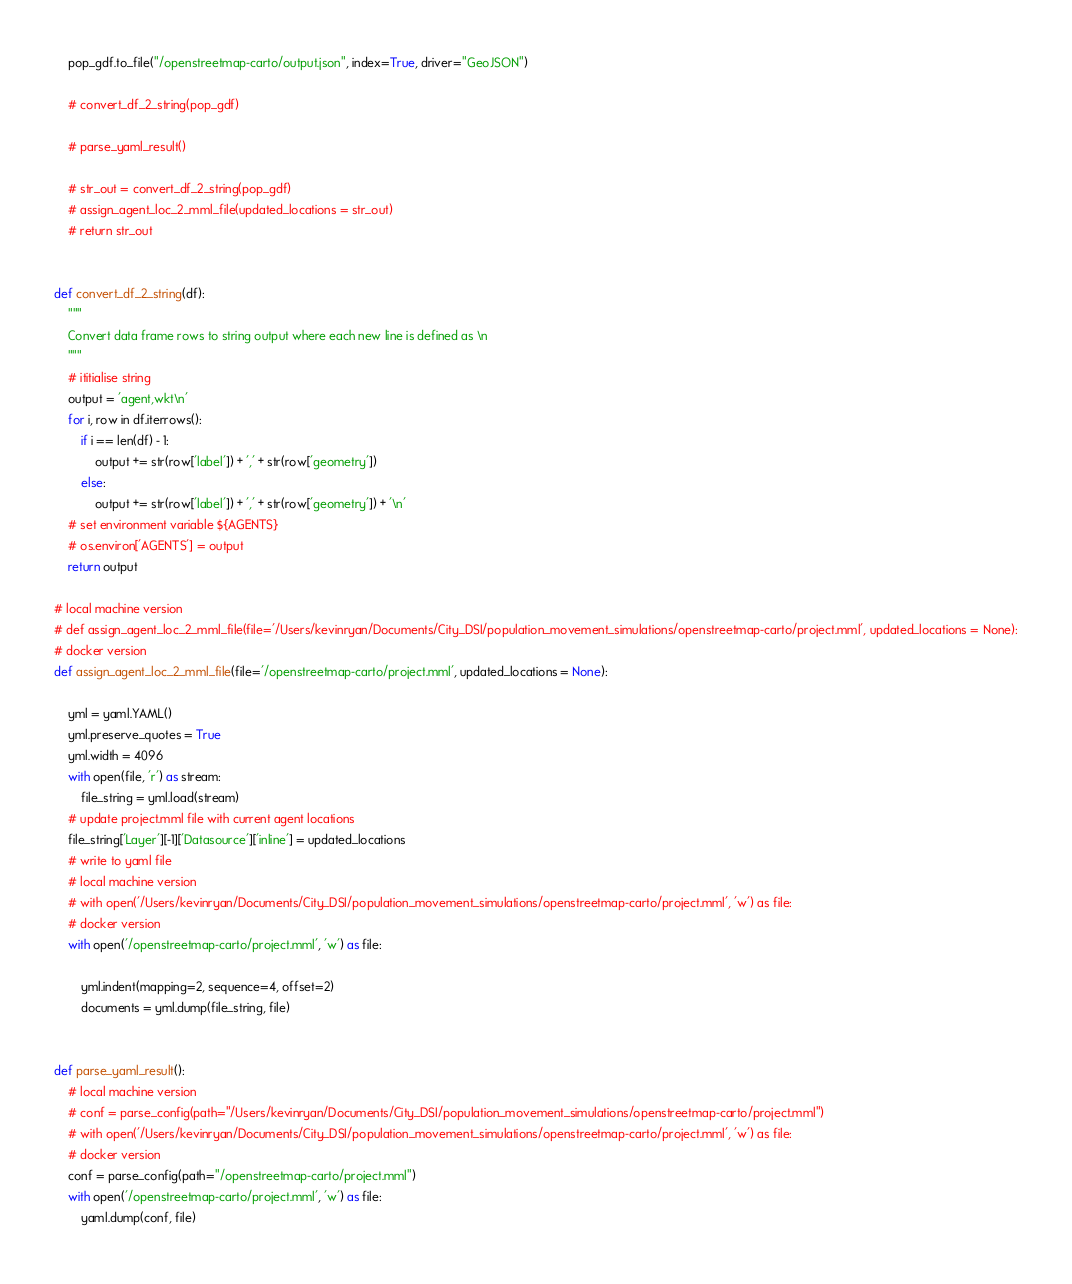Convert code to text. <code><loc_0><loc_0><loc_500><loc_500><_Python_>    pop_gdf.to_file("/openstreetmap-carto/output.json", index=True, driver="GeoJSON")

    # convert_df_2_string(pop_gdf)

    # parse_yaml_result()

    # str_out = convert_df_2_string(pop_gdf)
    # assign_agent_loc_2_mml_file(updated_locations = str_out)
    # return str_out


def convert_df_2_string(df):
    """
    Convert data frame rows to string output where each new line is defined as \n
    """
    # ititialise string
    output = 'agent,wkt\n'
    for i, row in df.iterrows():
        if i == len(df) - 1:
            output += str(row['label']) + ',' + str(row['geometry'])
        else:
            output += str(row['label']) + ',' + str(row['geometry']) + '\n'
    # set environment variable ${AGENTS}
    # os.environ['AGENTS'] = output
    return output

# local machine version
# def assign_agent_loc_2_mml_file(file='/Users/kevinryan/Documents/City_DSI/population_movement_simulations/openstreetmap-carto/project.mml', updated_locations = None):
# docker version
def assign_agent_loc_2_mml_file(file='/openstreetmap-carto/project.mml', updated_locations = None):

    yml = yaml.YAML()
    yml.preserve_quotes = True
    yml.width = 4096
    with open(file, 'r') as stream:
        file_string = yml.load(stream)
    # update project.mml file with current agent locations
    file_string['Layer'][-1]['Datasource']['inline'] = updated_locations
    # write to yaml file
    # local machine version
    # with open('/Users/kevinryan/Documents/City_DSI/population_movement_simulations/openstreetmap-carto/project.mml', 'w') as file:
    # docker version
    with open('/openstreetmap-carto/project.mml', 'w') as file:

        yml.indent(mapping=2, sequence=4, offset=2)
        documents = yml.dump(file_string, file)


def parse_yaml_result():
    # local machine version
    # conf = parse_config(path="/Users/kevinryan/Documents/City_DSI/population_movement_simulations/openstreetmap-carto/project.mml")
    # with open('/Users/kevinryan/Documents/City_DSI/population_movement_simulations/openstreetmap-carto/project.mml', 'w') as file:
    # docker version
    conf = parse_config(path="/openstreetmap-carto/project.mml")
    with open('/openstreetmap-carto/project.mml', 'w') as file:
        yaml.dump(conf, file)




</code> 